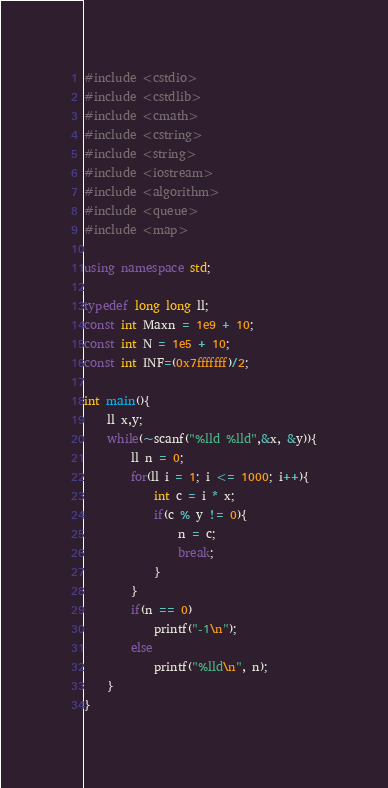<code> <loc_0><loc_0><loc_500><loc_500><_C++_>#include <cstdio>
#include <cstdlib>
#include <cmath>
#include <cstring>
#include <string>
#include <iostream>
#include <algorithm>
#include <queue>
#include <map>

using namespace std;

typedef long long ll;
const int Maxn = 1e9 + 10;
const int N = 1e5 + 10;
const int INF=(0x7fffffff)/2;

int main(){
    ll x,y;
    while(~scanf("%lld %lld",&x, &y)){
    	ll n = 0;
		for(ll i = 1; i <= 1000; i++){
			int c = i * x;
			if(c % y != 0){
				n = c;
				break;
			}
		}
		if(n == 0)
			printf("-1\n");
		else
			printf("%lld\n", n);
	}
}
</code> 